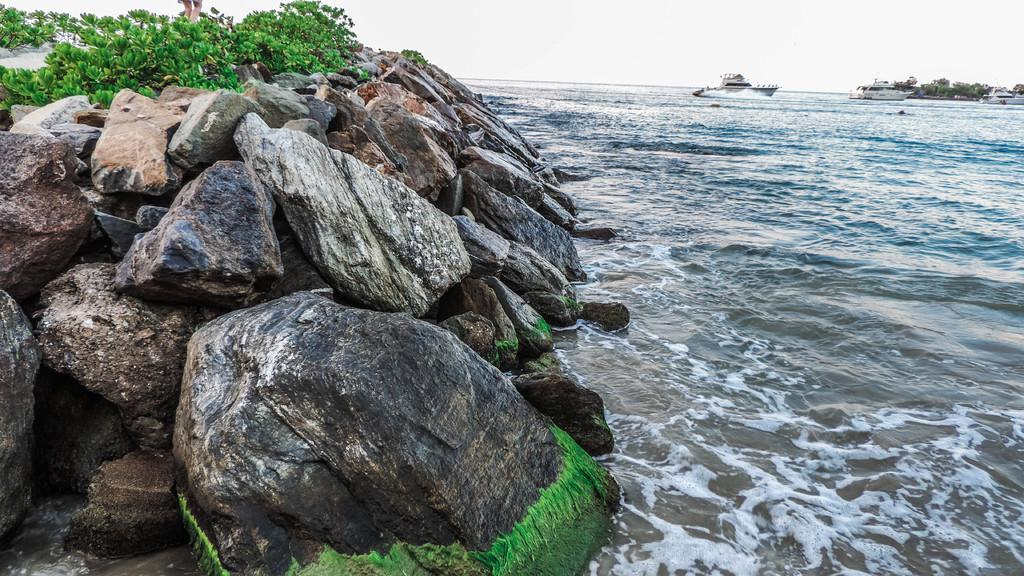What is located on the left side of the image? There are stones on the left side of the image. What is growing on the stones? There are plants on the stones. What can be seen on the right side of the image? There are boats on the right side of the image. Where are the boats situated? The boats are in the water. How many rings are visible on the boats in the image? There are no rings visible on the boats in the image. What type of yard is present in the image? There is no yard present in the image; it features stones, plants, and boats in the water. 